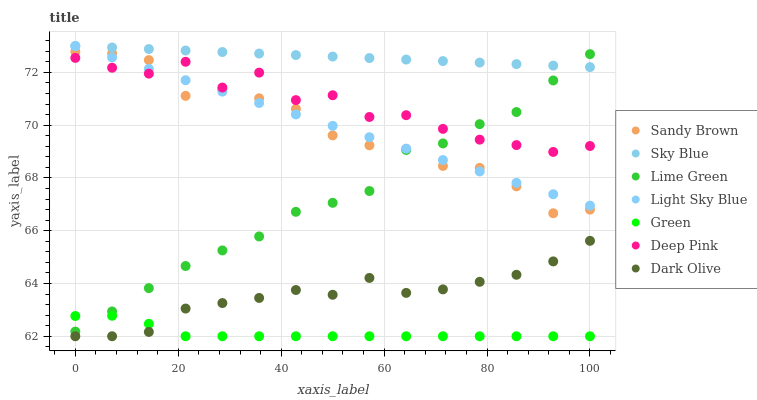Does Green have the minimum area under the curve?
Answer yes or no. Yes. Does Sky Blue have the maximum area under the curve?
Answer yes or no. Yes. Does Lime Green have the minimum area under the curve?
Answer yes or no. No. Does Lime Green have the maximum area under the curve?
Answer yes or no. No. Is Light Sky Blue the smoothest?
Answer yes or no. Yes. Is Deep Pink the roughest?
Answer yes or no. Yes. Is Lime Green the smoothest?
Answer yes or no. No. Is Lime Green the roughest?
Answer yes or no. No. Does Dark Olive have the lowest value?
Answer yes or no. Yes. Does Lime Green have the lowest value?
Answer yes or no. No. Does Sky Blue have the highest value?
Answer yes or no. Yes. Does Lime Green have the highest value?
Answer yes or no. No. Is Green less than Light Sky Blue?
Answer yes or no. Yes. Is Light Sky Blue greater than Dark Olive?
Answer yes or no. Yes. Does Light Sky Blue intersect Deep Pink?
Answer yes or no. Yes. Is Light Sky Blue less than Deep Pink?
Answer yes or no. No. Is Light Sky Blue greater than Deep Pink?
Answer yes or no. No. Does Green intersect Light Sky Blue?
Answer yes or no. No. 